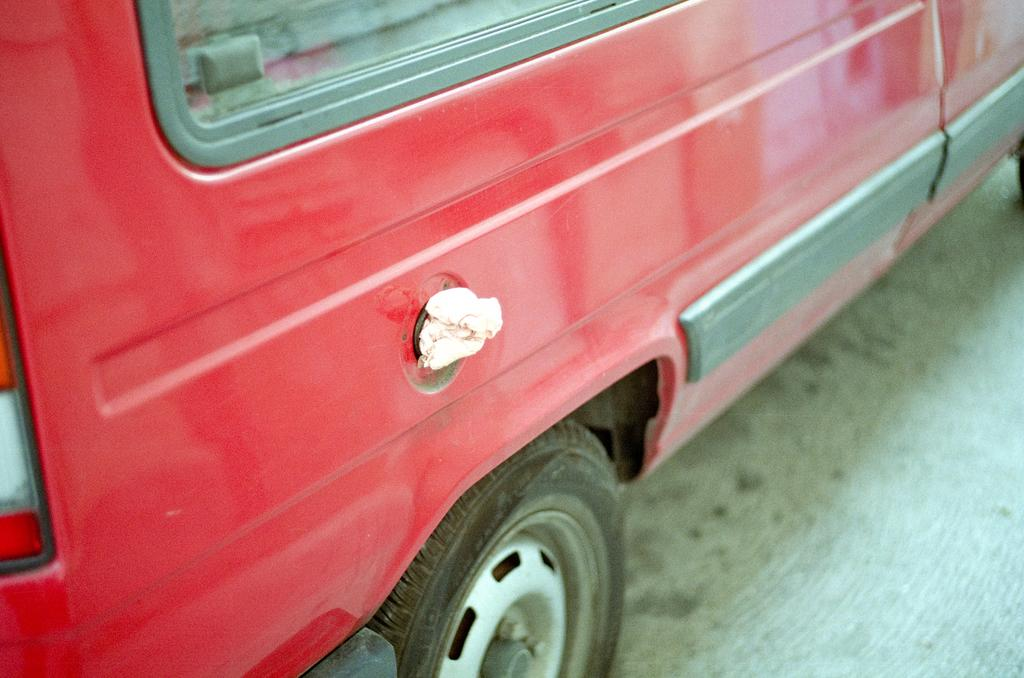What color is the vehicle in the image? The vehicle in the image is red. What is the position of the vehicle in the image? The vehicle is on the ground. What type of haircut is the vehicle getting in the image? There is no haircut present in the image, as the subject is a vehicle and not a person. 